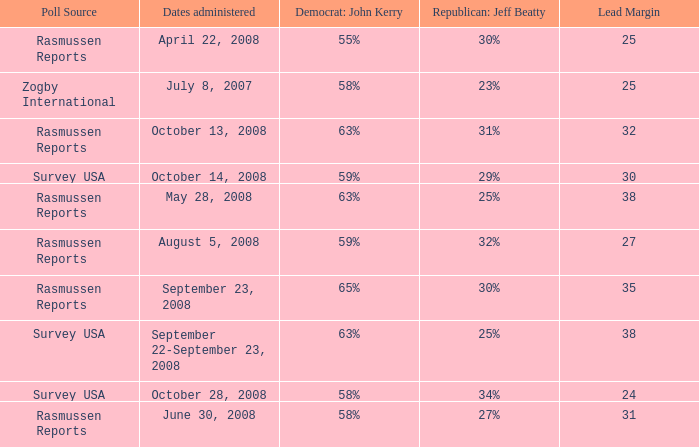What percent is the lead margin of 25 that Republican: Jeff Beatty has according to poll source Rasmussen Reports? 30%. 